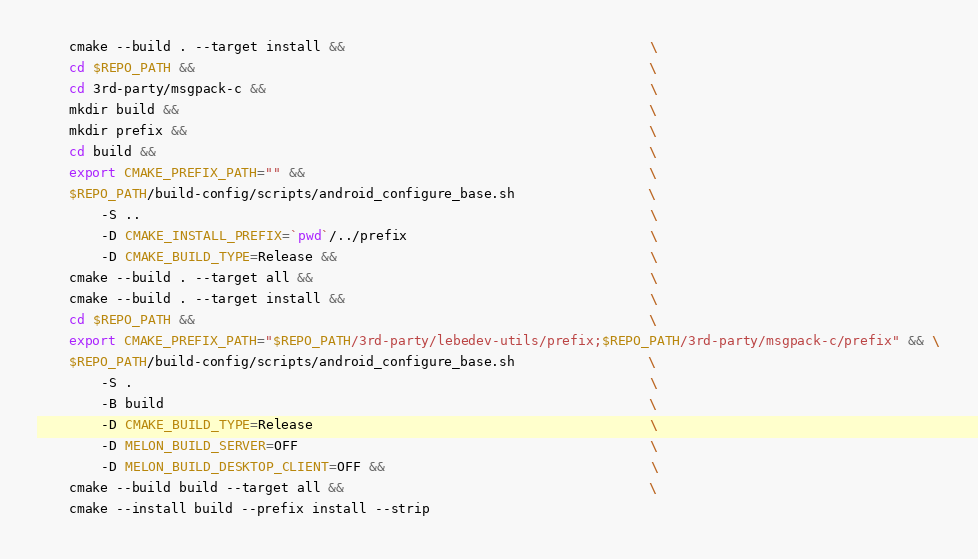<code> <loc_0><loc_0><loc_500><loc_500><_Dockerfile_>    cmake --build . --target install &&                                       \
    cd $REPO_PATH &&                                                          \
    cd 3rd-party/msgpack-c &&                                                 \
    mkdir build &&                                                            \
    mkdir prefix &&                                                           \
    cd build &&                                                               \
    export CMAKE_PREFIX_PATH="" &&                                            \
    $REPO_PATH/build-config/scripts/android_configure_base.sh                 \
        -S ..                                                                 \
        -D CMAKE_INSTALL_PREFIX=`pwd`/../prefix                               \
        -D CMAKE_BUILD_TYPE=Release &&                                        \
    cmake --build . --target all &&                                           \
    cmake --build . --target install &&                                       \
    cd $REPO_PATH &&                                                          \
    export CMAKE_PREFIX_PATH="$REPO_PATH/3rd-party/lebedev-utils/prefix;$REPO_PATH/3rd-party/msgpack-c/prefix" && \
    $REPO_PATH/build-config/scripts/android_configure_base.sh                 \
        -S .                                                                  \
        -B build                                                              \
        -D CMAKE_BUILD_TYPE=Release                                           \
        -D MELON_BUILD_SERVER=OFF                                             \
        -D MELON_BUILD_DESKTOP_CLIENT=OFF &&                                  \
    cmake --build build --target all &&                                       \
    cmake --install build --prefix install --strip
</code> 